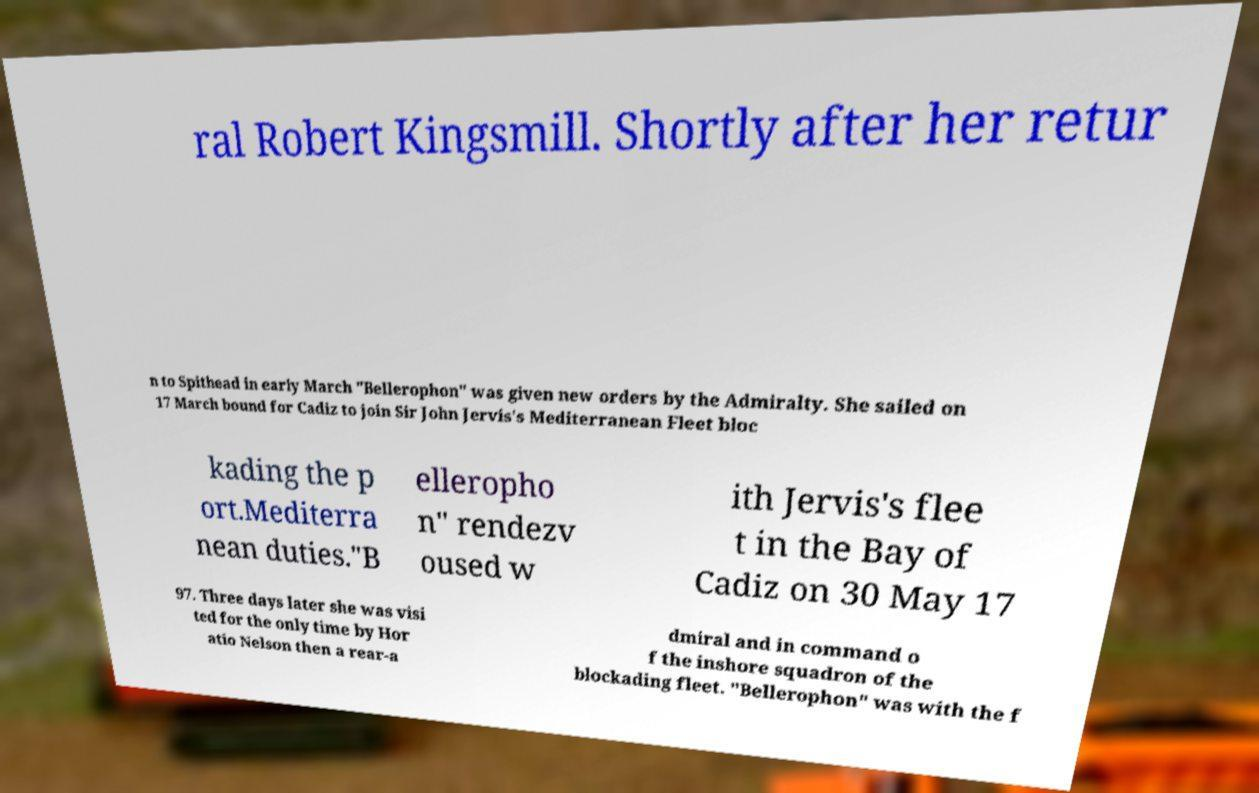Can you accurately transcribe the text from the provided image for me? ral Robert Kingsmill. Shortly after her retur n to Spithead in early March "Bellerophon" was given new orders by the Admiralty. She sailed on 17 March bound for Cadiz to join Sir John Jervis's Mediterranean Fleet bloc kading the p ort.Mediterra nean duties."B elleropho n" rendezv oused w ith Jervis's flee t in the Bay of Cadiz on 30 May 17 97. Three days later she was visi ted for the only time by Hor atio Nelson then a rear-a dmiral and in command o f the inshore squadron of the blockading fleet. "Bellerophon" was with the f 